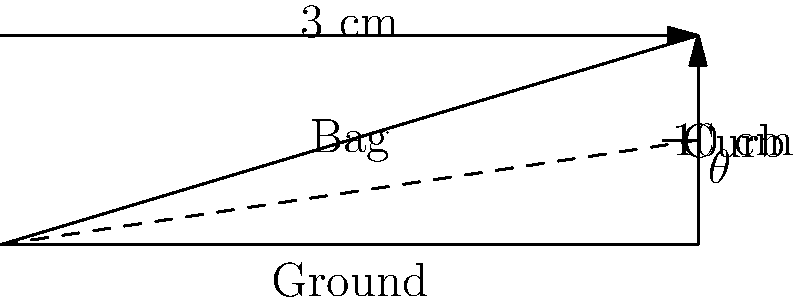As a marketing manager for a travel gear company, you're developing a wheeled carry-on bag that can easily roll up curbs. Your engineers have determined that the bag rolls most efficiently when the angle of incline is 15°. If a typical curb is 3 cm high, what should be the minimum length of the bag's telescoping handle to achieve this optimal angle? Round your answer to the nearest centimeter. Let's approach this step-by-step:

1) First, we need to understand what we're looking for. We want to find the length of the hypotenuse of the right triangle formed by the bag, the ground, and the handle.

2) We know two things:
   - The angle of incline (θ) should be 15°
   - The height of the curb is 3 cm (which is the opposite side of our triangle)

3) We can use the trigonometric relationship for sine:

   $$\sin \theta = \frac{\text{opposite}}{\text{hypotenuse}}$$

4) Plugging in our known values:

   $$\sin 15° = \frac{3}{\text{hypotenuse}}$$

5) To solve for the hypotenuse:

   $$\text{hypotenuse} = \frac{3}{\sin 15°}$$

6) Using a calculator (or trigonometric tables):

   $$\text{hypotenuse} = \frac{3}{0.2588} \approx 11.59 \text{ cm}$$

7) Rounding to the nearest centimeter:

   $$\text{hypotenuse} \approx 12 \text{ cm}$$

Therefore, the minimum length of the bag's telescoping handle should be 12 cm to achieve the optimal 15° angle of incline for a 3 cm high curb.
Answer: 12 cm 